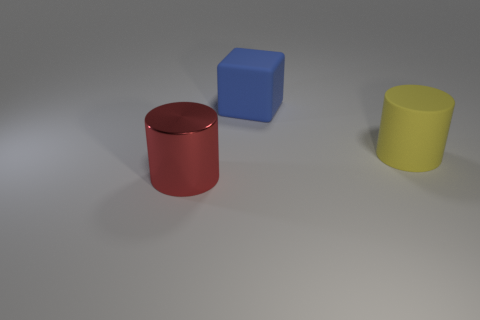Is there a big blue rubber block on the right side of the rubber thing behind the big yellow object?
Make the answer very short. No. Are the thing to the left of the cube and the blue cube made of the same material?
Give a very brief answer. No. Do the rubber block and the shiny object have the same color?
Ensure brevity in your answer.  No. What is the size of the rubber thing that is on the right side of the rubber thing on the left side of the rubber cylinder?
Your response must be concise. Large. Does the large thing behind the large rubber cylinder have the same material as the big cylinder that is behind the large shiny thing?
Ensure brevity in your answer.  Yes. Is the color of the rubber thing to the right of the blue matte object the same as the block?
Offer a terse response. No. What number of metal cylinders are behind the large yellow rubber object?
Your answer should be very brief. 0. Does the yellow cylinder have the same material as the thing in front of the large yellow thing?
Your answer should be very brief. No. What size is the blue cube that is made of the same material as the yellow cylinder?
Offer a very short reply. Large. Is the number of big blue blocks that are in front of the red object greater than the number of large yellow rubber cylinders on the right side of the big block?
Ensure brevity in your answer.  No. 